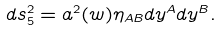<formula> <loc_0><loc_0><loc_500><loc_500>d s _ { 5 } ^ { 2 } = a ^ { 2 } ( w ) \eta _ { A B } d y ^ { A } d y ^ { B } .</formula> 